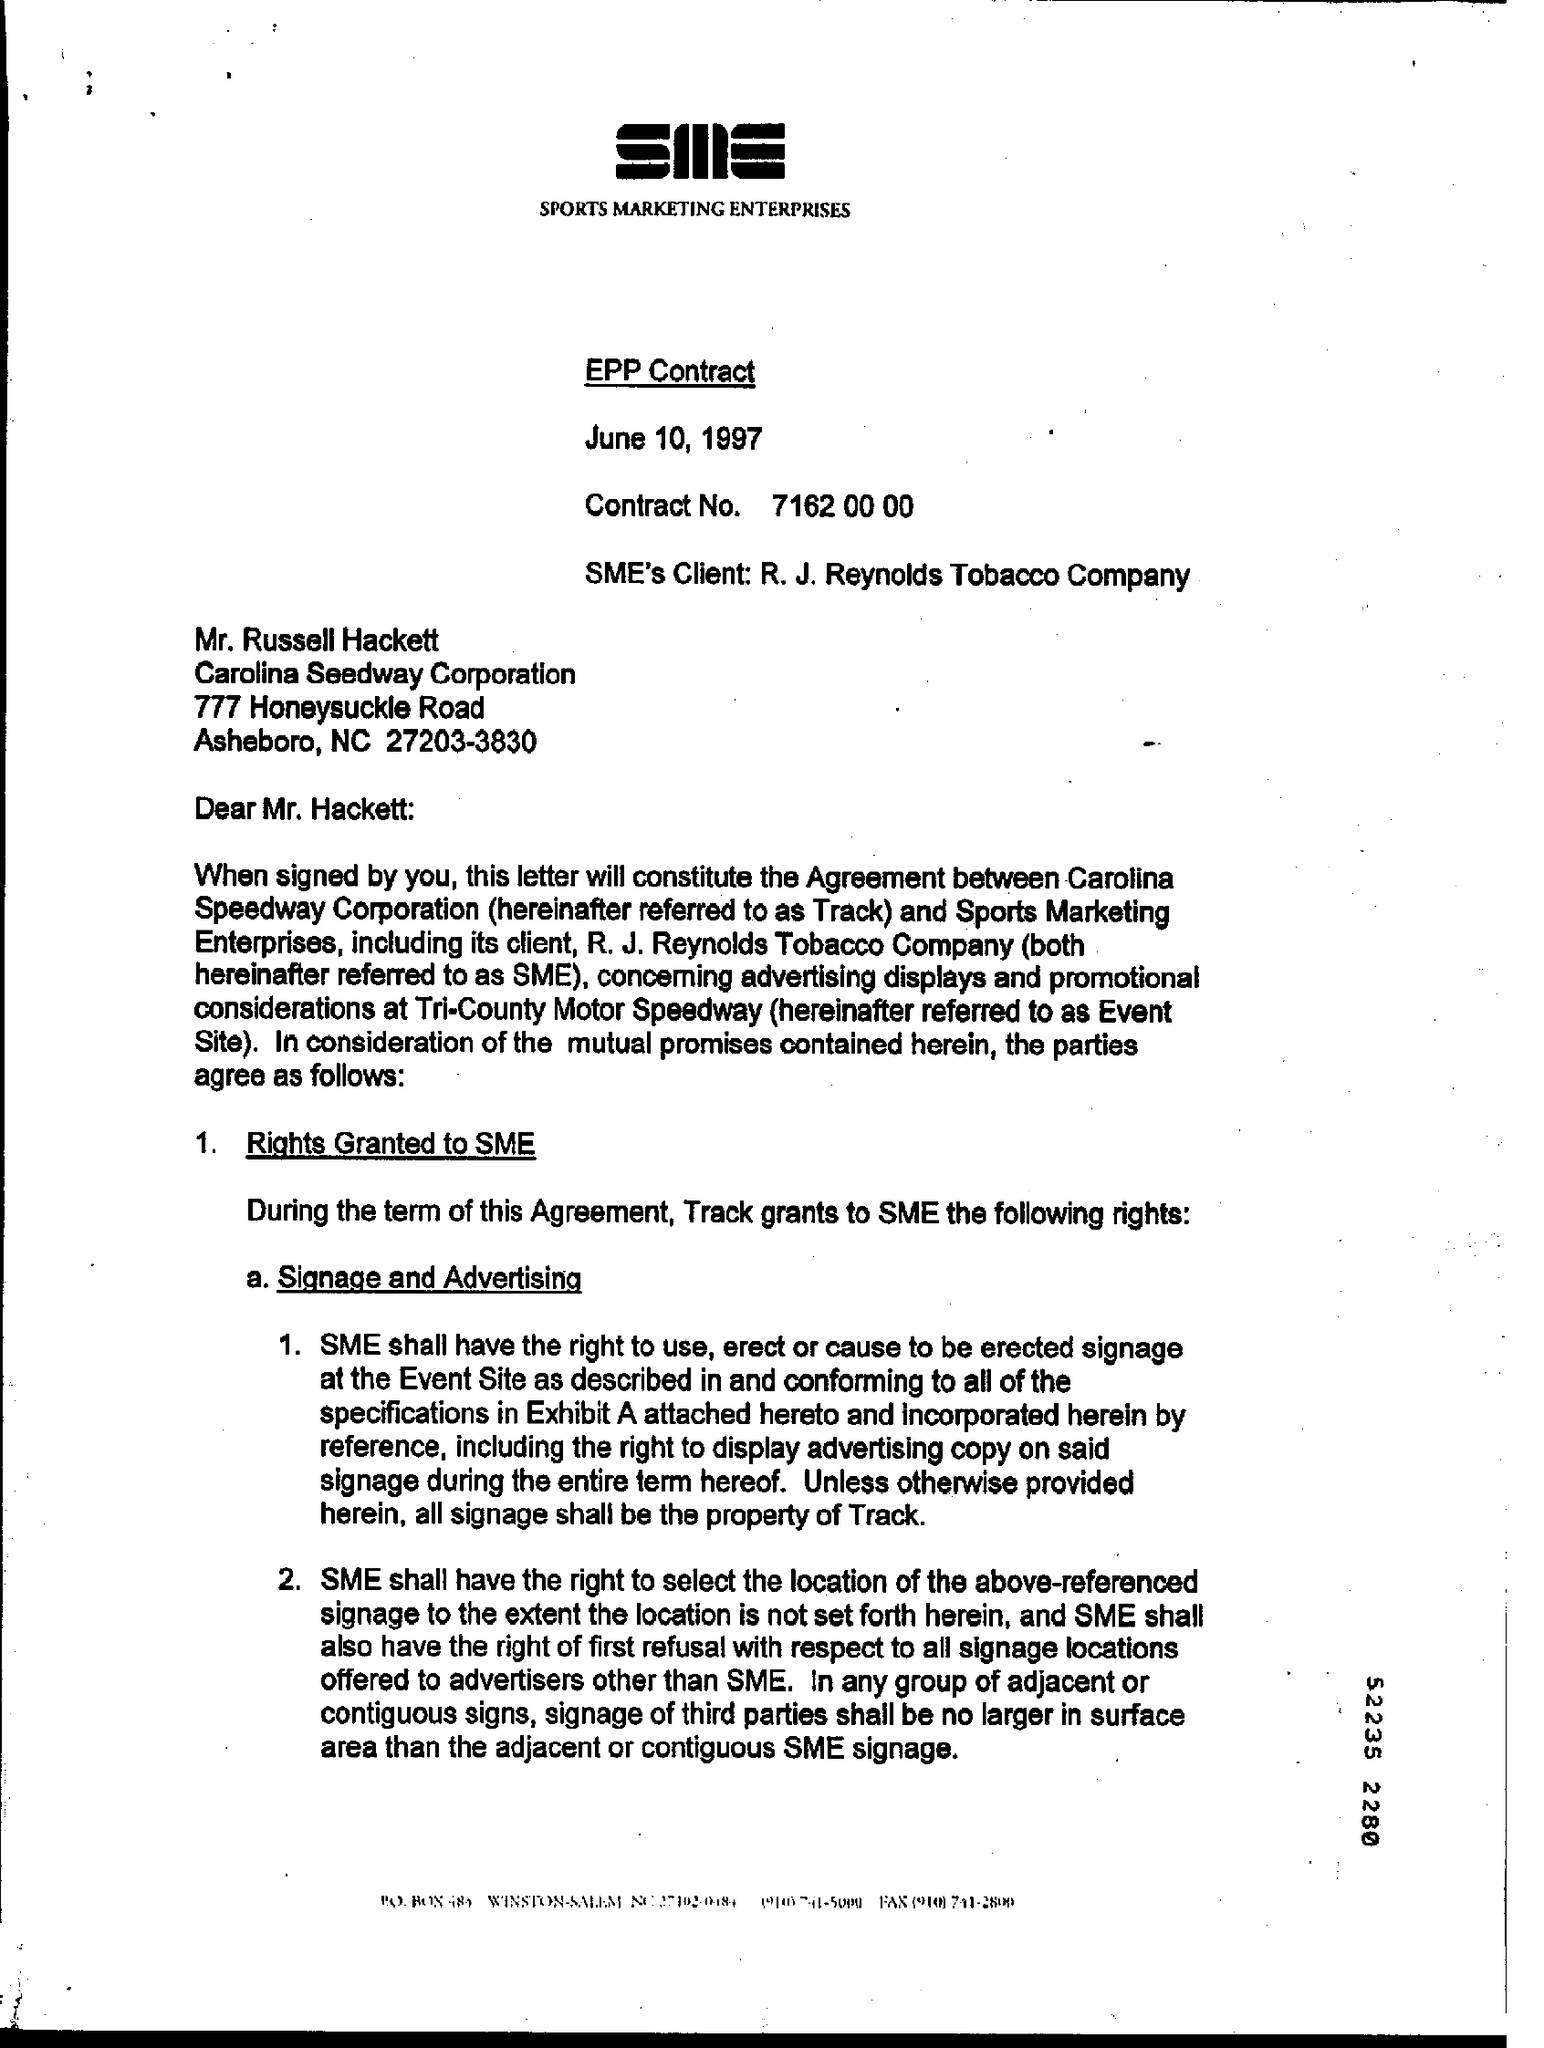What is the Contract No.?
Give a very brief answer. 7162 00 00. Who is the SME's Client?
Give a very brief answer. R. J. Reynolds Tobacco Company. Which company is Mr. Russell Hackett from?
Your answer should be very brief. Carolina Seedway Corporation. 